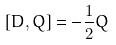<formula> <loc_0><loc_0><loc_500><loc_500>[ D , Q ] = - \frac { 1 } { 2 } Q</formula> 